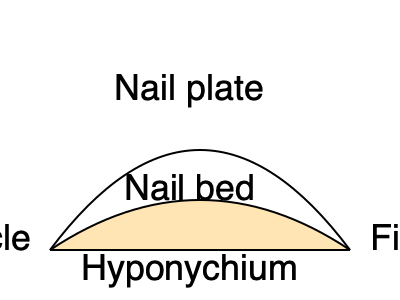In the cross-section diagram of a fingernail, which part is responsible for producing new nail cells and is located beneath the visible nail plate? To answer this question, let's break down the anatomy of a fingernail:

1. The visible part of the nail that we see and paint is called the nail plate. It's the hard, protective layer made of keratin.

2. Beneath the nail plate is the nail bed. This is a layer of living tissue that's rich in blood vessels, giving the nail its pink color.

3. The cuticle is the protective layer of skin at the base of the nail, where the nail emerges from the finger.

4. The hyponychium is the skin underneath the free edge of the nail, where the nail separates from the fingertip.

5. The part responsible for producing new nail cells is not directly visible in this cross-section, but it's located beneath the nail plate and is called the nail matrix.

The nail matrix is the living part of the nail unit that produces cells that become the nail plate. It's located under the skin at the base of the nail, extending from beneath the cuticle to the white half-moon shape (lunula) visible on some nails.

While the nail bed supports and nourishes the nail plate, it's the nail matrix that actually generates new nail cells, causing the nail to grow.
Answer: Nail matrix 